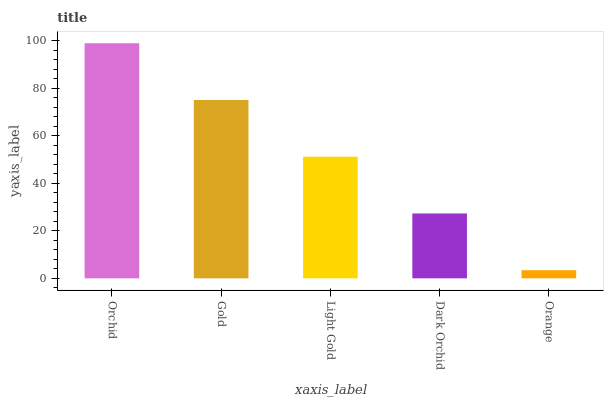Is Orange the minimum?
Answer yes or no. Yes. Is Orchid the maximum?
Answer yes or no. Yes. Is Gold the minimum?
Answer yes or no. No. Is Gold the maximum?
Answer yes or no. No. Is Orchid greater than Gold?
Answer yes or no. Yes. Is Gold less than Orchid?
Answer yes or no. Yes. Is Gold greater than Orchid?
Answer yes or no. No. Is Orchid less than Gold?
Answer yes or no. No. Is Light Gold the high median?
Answer yes or no. Yes. Is Light Gold the low median?
Answer yes or no. Yes. Is Gold the high median?
Answer yes or no. No. Is Orchid the low median?
Answer yes or no. No. 